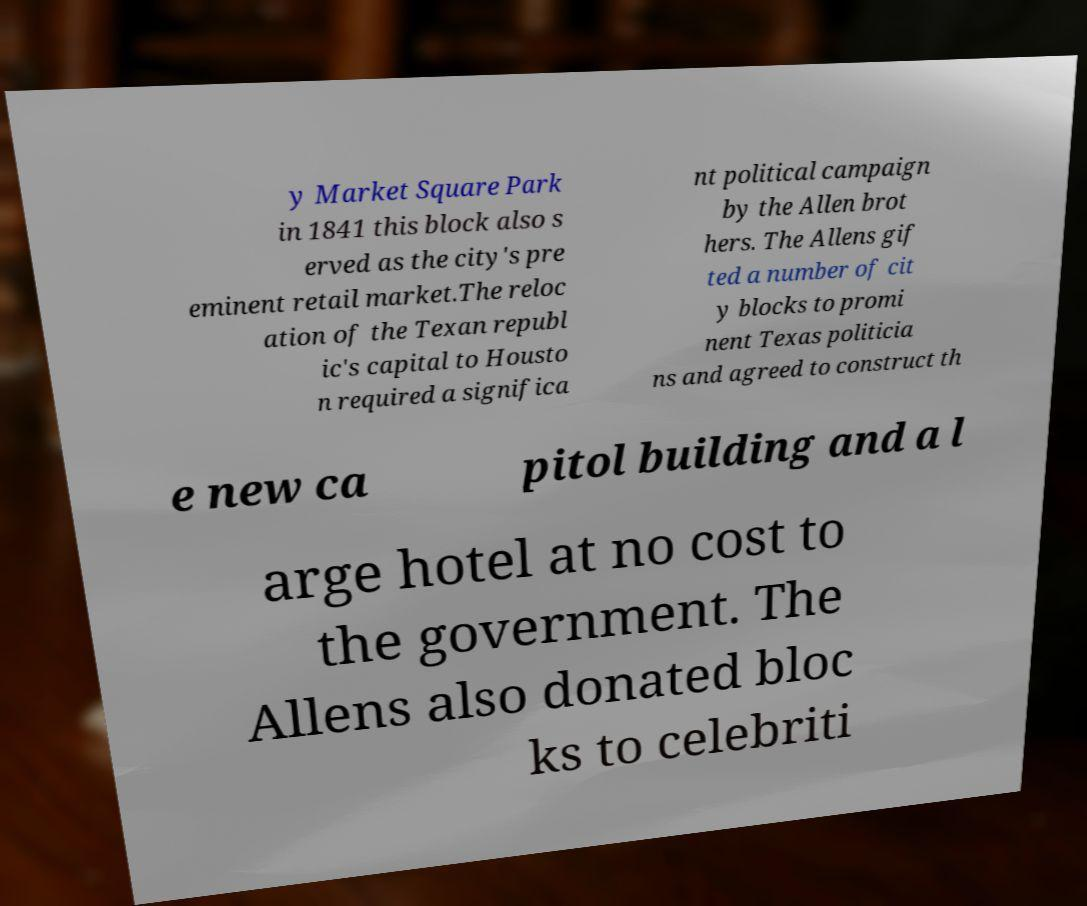Can you read and provide the text displayed in the image?This photo seems to have some interesting text. Can you extract and type it out for me? y Market Square Park in 1841 this block also s erved as the city's pre eminent retail market.The reloc ation of the Texan republ ic's capital to Housto n required a significa nt political campaign by the Allen brot hers. The Allens gif ted a number of cit y blocks to promi nent Texas politicia ns and agreed to construct th e new ca pitol building and a l arge hotel at no cost to the government. The Allens also donated bloc ks to celebriti 